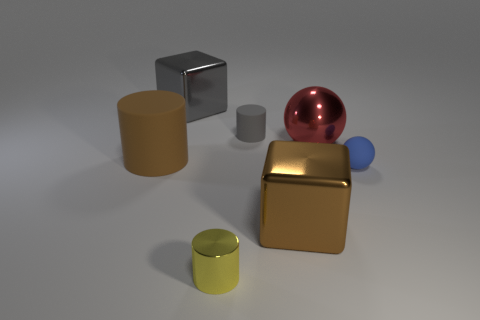Add 1 small blue things. How many objects exist? 8 Subtract all cylinders. How many objects are left? 4 Add 3 brown metallic objects. How many brown metallic objects are left? 4 Add 5 yellow metallic blocks. How many yellow metallic blocks exist? 5 Subtract 0 green spheres. How many objects are left? 7 Subtract all tiny red rubber cylinders. Subtract all small gray matte objects. How many objects are left? 6 